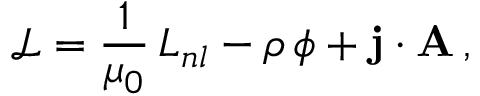Convert formula to latex. <formula><loc_0><loc_0><loc_500><loc_500>\mathcal { L } = \frac { 1 } { \mu _ { 0 } } \, L _ { n l } - \rho \, \phi + { j } \cdot { A } \, ,</formula> 